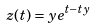<formula> <loc_0><loc_0><loc_500><loc_500>z ( t ) = y e ^ { t - t y }</formula> 